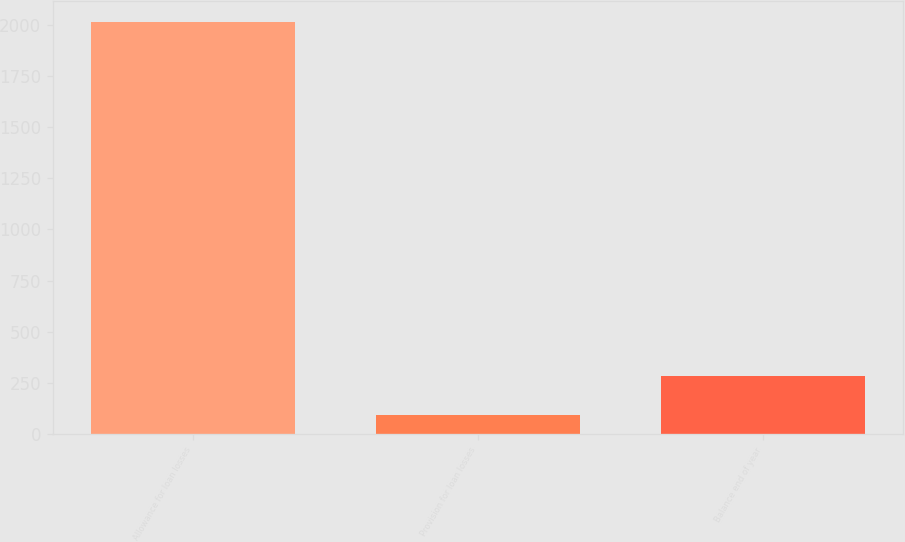Convert chart. <chart><loc_0><loc_0><loc_500><loc_500><bar_chart><fcel>Allowance for loan losses<fcel>Provision for loan losses<fcel>Balance end of year<nl><fcel>2014<fcel>92<fcel>284.2<nl></chart> 